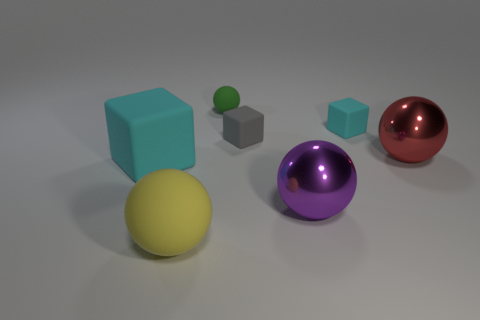Subtract 1 spheres. How many spheres are left? 3 Add 2 large yellow balls. How many objects exist? 9 Subtract all spheres. How many objects are left? 3 Subtract all brown metallic blocks. Subtract all large rubber cubes. How many objects are left? 6 Add 7 small rubber blocks. How many small rubber blocks are left? 9 Add 2 big red objects. How many big red objects exist? 3 Subtract 0 yellow cylinders. How many objects are left? 7 